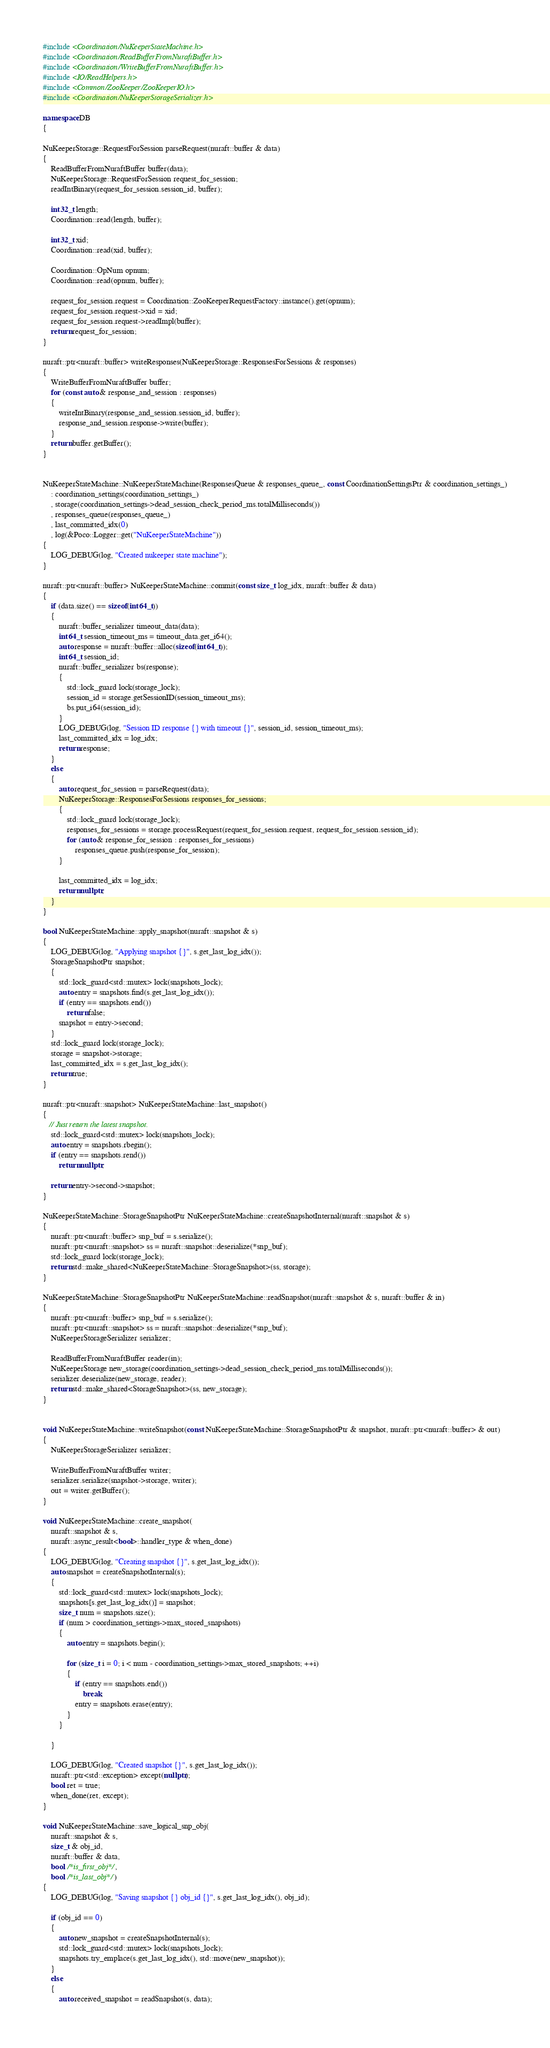<code> <loc_0><loc_0><loc_500><loc_500><_C++_>#include <Coordination/NuKeeperStateMachine.h>
#include <Coordination/ReadBufferFromNuraftBuffer.h>
#include <Coordination/WriteBufferFromNuraftBuffer.h>
#include <IO/ReadHelpers.h>
#include <Common/ZooKeeper/ZooKeeperIO.h>
#include <Coordination/NuKeeperStorageSerializer.h>

namespace DB
{

NuKeeperStorage::RequestForSession parseRequest(nuraft::buffer & data)
{
    ReadBufferFromNuraftBuffer buffer(data);
    NuKeeperStorage::RequestForSession request_for_session;
    readIntBinary(request_for_session.session_id, buffer);

    int32_t length;
    Coordination::read(length, buffer);

    int32_t xid;
    Coordination::read(xid, buffer);

    Coordination::OpNum opnum;
    Coordination::read(opnum, buffer);

    request_for_session.request = Coordination::ZooKeeperRequestFactory::instance().get(opnum);
    request_for_session.request->xid = xid;
    request_for_session.request->readImpl(buffer);
    return request_for_session;
}

nuraft::ptr<nuraft::buffer> writeResponses(NuKeeperStorage::ResponsesForSessions & responses)
{
    WriteBufferFromNuraftBuffer buffer;
    for (const auto & response_and_session : responses)
    {
        writeIntBinary(response_and_session.session_id, buffer);
        response_and_session.response->write(buffer);
    }
    return buffer.getBuffer();
}


NuKeeperStateMachine::NuKeeperStateMachine(ResponsesQueue & responses_queue_, const CoordinationSettingsPtr & coordination_settings_)
    : coordination_settings(coordination_settings_)
    , storage(coordination_settings->dead_session_check_period_ms.totalMilliseconds())
    , responses_queue(responses_queue_)
    , last_committed_idx(0)
    , log(&Poco::Logger::get("NuKeeperStateMachine"))
{
    LOG_DEBUG(log, "Created nukeeper state machine");
}

nuraft::ptr<nuraft::buffer> NuKeeperStateMachine::commit(const size_t log_idx, nuraft::buffer & data)
{
    if (data.size() == sizeof(int64_t))
    {
        nuraft::buffer_serializer timeout_data(data);
        int64_t session_timeout_ms = timeout_data.get_i64();
        auto response = nuraft::buffer::alloc(sizeof(int64_t));
        int64_t session_id;
        nuraft::buffer_serializer bs(response);
        {
            std::lock_guard lock(storage_lock);
            session_id = storage.getSessionID(session_timeout_ms);
            bs.put_i64(session_id);
        }
        LOG_DEBUG(log, "Session ID response {} with timeout {}", session_id, session_timeout_ms);
        last_committed_idx = log_idx;
        return response;
    }
    else
    {
        auto request_for_session = parseRequest(data);
        NuKeeperStorage::ResponsesForSessions responses_for_sessions;
        {
            std::lock_guard lock(storage_lock);
            responses_for_sessions = storage.processRequest(request_for_session.request, request_for_session.session_id);
            for (auto & response_for_session : responses_for_sessions)
                responses_queue.push(response_for_session);
        }

        last_committed_idx = log_idx;
        return nullptr;
    }
}

bool NuKeeperStateMachine::apply_snapshot(nuraft::snapshot & s)
{
    LOG_DEBUG(log, "Applying snapshot {}", s.get_last_log_idx());
    StorageSnapshotPtr snapshot;
    {
        std::lock_guard<std::mutex> lock(snapshots_lock);
        auto entry = snapshots.find(s.get_last_log_idx());
        if (entry == snapshots.end())
            return false;
        snapshot = entry->second;
    }
    std::lock_guard lock(storage_lock);
    storage = snapshot->storage;
    last_committed_idx = s.get_last_log_idx();
    return true;
}

nuraft::ptr<nuraft::snapshot> NuKeeperStateMachine::last_snapshot()
{
   // Just return the latest snapshot.
    std::lock_guard<std::mutex> lock(snapshots_lock);
    auto entry = snapshots.rbegin();
    if (entry == snapshots.rend())
        return nullptr;

    return entry->second->snapshot;
}

NuKeeperStateMachine::StorageSnapshotPtr NuKeeperStateMachine::createSnapshotInternal(nuraft::snapshot & s)
{
    nuraft::ptr<nuraft::buffer> snp_buf = s.serialize();
    nuraft::ptr<nuraft::snapshot> ss = nuraft::snapshot::deserialize(*snp_buf);
    std::lock_guard lock(storage_lock);
    return std::make_shared<NuKeeperStateMachine::StorageSnapshot>(ss, storage);
}

NuKeeperStateMachine::StorageSnapshotPtr NuKeeperStateMachine::readSnapshot(nuraft::snapshot & s, nuraft::buffer & in)
{
    nuraft::ptr<nuraft::buffer> snp_buf = s.serialize();
    nuraft::ptr<nuraft::snapshot> ss = nuraft::snapshot::deserialize(*snp_buf);
    NuKeeperStorageSerializer serializer;

    ReadBufferFromNuraftBuffer reader(in);
    NuKeeperStorage new_storage(coordination_settings->dead_session_check_period_ms.totalMilliseconds());
    serializer.deserialize(new_storage, reader);
    return std::make_shared<StorageSnapshot>(ss, new_storage);
}


void NuKeeperStateMachine::writeSnapshot(const NuKeeperStateMachine::StorageSnapshotPtr & snapshot, nuraft::ptr<nuraft::buffer> & out)
{
    NuKeeperStorageSerializer serializer;

    WriteBufferFromNuraftBuffer writer;
    serializer.serialize(snapshot->storage, writer);
    out = writer.getBuffer();
}

void NuKeeperStateMachine::create_snapshot(
    nuraft::snapshot & s,
    nuraft::async_result<bool>::handler_type & when_done)
{
    LOG_DEBUG(log, "Creating snapshot {}", s.get_last_log_idx());
    auto snapshot = createSnapshotInternal(s);
    {
        std::lock_guard<std::mutex> lock(snapshots_lock);
        snapshots[s.get_last_log_idx()] = snapshot;
        size_t num = snapshots.size();
        if (num > coordination_settings->max_stored_snapshots)
        {
            auto entry = snapshots.begin();

            for (size_t i = 0; i < num - coordination_settings->max_stored_snapshots; ++i)
            {
                if (entry == snapshots.end())
                    break;
                entry = snapshots.erase(entry);
            }
        }

    }

    LOG_DEBUG(log, "Created snapshot {}", s.get_last_log_idx());
    nuraft::ptr<std::exception> except(nullptr);
    bool ret = true;
    when_done(ret, except);
}

void NuKeeperStateMachine::save_logical_snp_obj(
    nuraft::snapshot & s,
    size_t & obj_id,
    nuraft::buffer & data,
    bool /*is_first_obj*/,
    bool /*is_last_obj*/)
{
    LOG_DEBUG(log, "Saving snapshot {} obj_id {}", s.get_last_log_idx(), obj_id);

    if (obj_id == 0)
    {
        auto new_snapshot = createSnapshotInternal(s);
        std::lock_guard<std::mutex> lock(snapshots_lock);
        snapshots.try_emplace(s.get_last_log_idx(), std::move(new_snapshot));
    }
    else
    {
        auto received_snapshot = readSnapshot(s, data);
</code> 